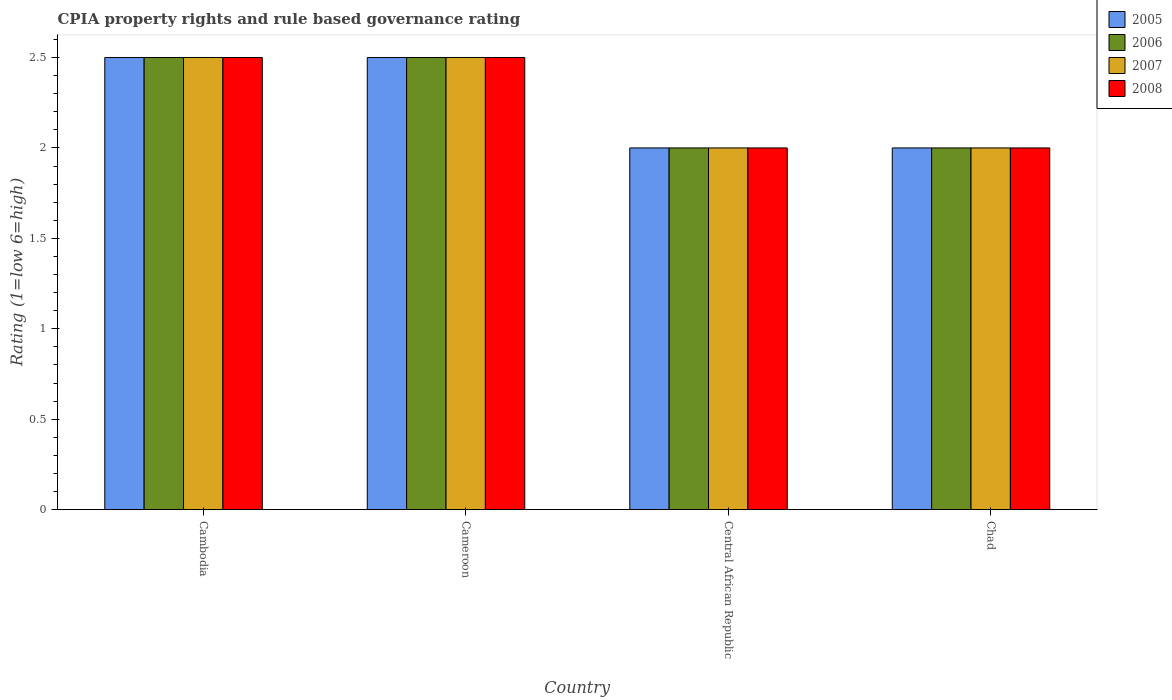Are the number of bars per tick equal to the number of legend labels?
Provide a succinct answer. Yes. Are the number of bars on each tick of the X-axis equal?
Offer a very short reply. Yes. How many bars are there on the 4th tick from the left?
Provide a succinct answer. 4. What is the label of the 4th group of bars from the left?
Provide a succinct answer. Chad. In how many cases, is the number of bars for a given country not equal to the number of legend labels?
Provide a succinct answer. 0. What is the CPIA rating in 2005 in Cambodia?
Provide a short and direct response. 2.5. Across all countries, what is the maximum CPIA rating in 2008?
Offer a terse response. 2.5. Across all countries, what is the minimum CPIA rating in 2008?
Your answer should be compact. 2. In which country was the CPIA rating in 2008 maximum?
Offer a terse response. Cambodia. In which country was the CPIA rating in 2007 minimum?
Your response must be concise. Central African Republic. What is the total CPIA rating in 2008 in the graph?
Provide a succinct answer. 9. What is the average CPIA rating in 2008 per country?
Provide a succinct answer. 2.25. What is the difference between the CPIA rating of/in 2005 and CPIA rating of/in 2008 in Central African Republic?
Offer a very short reply. 0. Is the CPIA rating in 2005 in Cambodia less than that in Central African Republic?
Your response must be concise. No. Is the difference between the CPIA rating in 2005 in Cameroon and Central African Republic greater than the difference between the CPIA rating in 2008 in Cameroon and Central African Republic?
Your response must be concise. No. In how many countries, is the CPIA rating in 2007 greater than the average CPIA rating in 2007 taken over all countries?
Provide a short and direct response. 2. How many bars are there?
Provide a succinct answer. 16. Are all the bars in the graph horizontal?
Your answer should be very brief. No. What is the difference between two consecutive major ticks on the Y-axis?
Give a very brief answer. 0.5. Does the graph contain grids?
Your answer should be very brief. No. Where does the legend appear in the graph?
Offer a terse response. Top right. How are the legend labels stacked?
Provide a short and direct response. Vertical. What is the title of the graph?
Offer a terse response. CPIA property rights and rule based governance rating. What is the label or title of the X-axis?
Your response must be concise. Country. What is the label or title of the Y-axis?
Your answer should be compact. Rating (1=low 6=high). What is the Rating (1=low 6=high) of 2005 in Cambodia?
Give a very brief answer. 2.5. What is the Rating (1=low 6=high) in 2006 in Cambodia?
Your response must be concise. 2.5. What is the Rating (1=low 6=high) of 2007 in Cambodia?
Ensure brevity in your answer.  2.5. What is the Rating (1=low 6=high) in 2008 in Cambodia?
Offer a very short reply. 2.5. What is the Rating (1=low 6=high) of 2005 in Cameroon?
Give a very brief answer. 2.5. What is the Rating (1=low 6=high) in 2008 in Cameroon?
Make the answer very short. 2.5. What is the Rating (1=low 6=high) of 2008 in Central African Republic?
Provide a succinct answer. 2. What is the Rating (1=low 6=high) of 2005 in Chad?
Your answer should be compact. 2. What is the Rating (1=low 6=high) in 2008 in Chad?
Keep it short and to the point. 2. Across all countries, what is the minimum Rating (1=low 6=high) of 2005?
Provide a succinct answer. 2. Across all countries, what is the minimum Rating (1=low 6=high) in 2006?
Provide a short and direct response. 2. Across all countries, what is the minimum Rating (1=low 6=high) of 2008?
Your answer should be very brief. 2. What is the total Rating (1=low 6=high) in 2006 in the graph?
Your answer should be very brief. 9. What is the total Rating (1=low 6=high) in 2008 in the graph?
Offer a terse response. 9. What is the difference between the Rating (1=low 6=high) in 2005 in Cambodia and that in Cameroon?
Your answer should be very brief. 0. What is the difference between the Rating (1=low 6=high) in 2007 in Cambodia and that in Cameroon?
Your response must be concise. 0. What is the difference between the Rating (1=low 6=high) in 2008 in Cambodia and that in Cameroon?
Offer a terse response. 0. What is the difference between the Rating (1=low 6=high) of 2005 in Cambodia and that in Central African Republic?
Provide a short and direct response. 0.5. What is the difference between the Rating (1=low 6=high) of 2006 in Cambodia and that in Central African Republic?
Give a very brief answer. 0.5. What is the difference between the Rating (1=low 6=high) of 2007 in Cambodia and that in Central African Republic?
Your response must be concise. 0.5. What is the difference between the Rating (1=low 6=high) of 2005 in Cambodia and that in Chad?
Your answer should be compact. 0.5. What is the difference between the Rating (1=low 6=high) in 2007 in Cambodia and that in Chad?
Your answer should be compact. 0.5. What is the difference between the Rating (1=low 6=high) of 2008 in Cambodia and that in Chad?
Your answer should be compact. 0.5. What is the difference between the Rating (1=low 6=high) of 2005 in Cameroon and that in Central African Republic?
Provide a short and direct response. 0.5. What is the difference between the Rating (1=low 6=high) of 2005 in Cameroon and that in Chad?
Your answer should be compact. 0.5. What is the difference between the Rating (1=low 6=high) in 2006 in Cameroon and that in Chad?
Make the answer very short. 0.5. What is the difference between the Rating (1=low 6=high) of 2007 in Cameroon and that in Chad?
Give a very brief answer. 0.5. What is the difference between the Rating (1=low 6=high) in 2005 in Central African Republic and that in Chad?
Provide a short and direct response. 0. What is the difference between the Rating (1=low 6=high) of 2006 in Central African Republic and that in Chad?
Your answer should be very brief. 0. What is the difference between the Rating (1=low 6=high) of 2007 in Central African Republic and that in Chad?
Your answer should be compact. 0. What is the difference between the Rating (1=low 6=high) of 2008 in Central African Republic and that in Chad?
Your answer should be very brief. 0. What is the difference between the Rating (1=low 6=high) in 2005 in Cambodia and the Rating (1=low 6=high) in 2006 in Cameroon?
Your answer should be compact. 0. What is the difference between the Rating (1=low 6=high) of 2005 in Cambodia and the Rating (1=low 6=high) of 2008 in Cameroon?
Provide a succinct answer. 0. What is the difference between the Rating (1=low 6=high) of 2006 in Cambodia and the Rating (1=low 6=high) of 2008 in Cameroon?
Give a very brief answer. 0. What is the difference between the Rating (1=low 6=high) of 2005 in Cambodia and the Rating (1=low 6=high) of 2007 in Central African Republic?
Your response must be concise. 0.5. What is the difference between the Rating (1=low 6=high) of 2006 in Cambodia and the Rating (1=low 6=high) of 2008 in Central African Republic?
Provide a succinct answer. 0.5. What is the difference between the Rating (1=low 6=high) in 2005 in Cambodia and the Rating (1=low 6=high) in 2006 in Chad?
Offer a very short reply. 0.5. What is the difference between the Rating (1=low 6=high) in 2005 in Cambodia and the Rating (1=low 6=high) in 2007 in Chad?
Offer a very short reply. 0.5. What is the difference between the Rating (1=low 6=high) of 2005 in Cameroon and the Rating (1=low 6=high) of 2006 in Central African Republic?
Offer a terse response. 0.5. What is the difference between the Rating (1=low 6=high) in 2007 in Cameroon and the Rating (1=low 6=high) in 2008 in Central African Republic?
Your answer should be very brief. 0.5. What is the difference between the Rating (1=low 6=high) of 2006 in Cameroon and the Rating (1=low 6=high) of 2007 in Chad?
Give a very brief answer. 0.5. What is the difference between the Rating (1=low 6=high) of 2005 in Central African Republic and the Rating (1=low 6=high) of 2007 in Chad?
Offer a very short reply. 0. What is the difference between the Rating (1=low 6=high) in 2006 in Central African Republic and the Rating (1=low 6=high) in 2008 in Chad?
Offer a terse response. 0. What is the difference between the Rating (1=low 6=high) in 2007 in Central African Republic and the Rating (1=low 6=high) in 2008 in Chad?
Your answer should be compact. 0. What is the average Rating (1=low 6=high) of 2005 per country?
Make the answer very short. 2.25. What is the average Rating (1=low 6=high) of 2006 per country?
Provide a short and direct response. 2.25. What is the average Rating (1=low 6=high) in 2007 per country?
Ensure brevity in your answer.  2.25. What is the average Rating (1=low 6=high) in 2008 per country?
Make the answer very short. 2.25. What is the difference between the Rating (1=low 6=high) of 2005 and Rating (1=low 6=high) of 2006 in Cambodia?
Provide a short and direct response. 0. What is the difference between the Rating (1=low 6=high) of 2005 and Rating (1=low 6=high) of 2007 in Cambodia?
Your answer should be very brief. 0. What is the difference between the Rating (1=low 6=high) in 2005 and Rating (1=low 6=high) in 2008 in Cambodia?
Your answer should be compact. 0. What is the difference between the Rating (1=low 6=high) in 2007 and Rating (1=low 6=high) in 2008 in Cambodia?
Keep it short and to the point. 0. What is the difference between the Rating (1=low 6=high) in 2005 and Rating (1=low 6=high) in 2006 in Cameroon?
Your answer should be compact. 0. What is the difference between the Rating (1=low 6=high) in 2005 and Rating (1=low 6=high) in 2007 in Cameroon?
Offer a very short reply. 0. What is the difference between the Rating (1=low 6=high) of 2006 and Rating (1=low 6=high) of 2007 in Cameroon?
Your response must be concise. 0. What is the difference between the Rating (1=low 6=high) of 2007 and Rating (1=low 6=high) of 2008 in Cameroon?
Your response must be concise. 0. What is the difference between the Rating (1=low 6=high) of 2005 and Rating (1=low 6=high) of 2007 in Central African Republic?
Ensure brevity in your answer.  0. What is the difference between the Rating (1=low 6=high) in 2005 and Rating (1=low 6=high) in 2008 in Central African Republic?
Keep it short and to the point. 0. What is the difference between the Rating (1=low 6=high) of 2006 and Rating (1=low 6=high) of 2007 in Central African Republic?
Your answer should be very brief. 0. What is the difference between the Rating (1=low 6=high) of 2005 and Rating (1=low 6=high) of 2006 in Chad?
Give a very brief answer. 0. What is the difference between the Rating (1=low 6=high) of 2005 and Rating (1=low 6=high) of 2008 in Chad?
Your response must be concise. 0. What is the difference between the Rating (1=low 6=high) of 2006 and Rating (1=low 6=high) of 2007 in Chad?
Keep it short and to the point. 0. What is the ratio of the Rating (1=low 6=high) in 2008 in Cambodia to that in Cameroon?
Ensure brevity in your answer.  1. What is the ratio of the Rating (1=low 6=high) of 2006 in Cambodia to that in Central African Republic?
Provide a succinct answer. 1.25. What is the ratio of the Rating (1=low 6=high) in 2005 in Cambodia to that in Chad?
Provide a succinct answer. 1.25. What is the ratio of the Rating (1=low 6=high) in 2006 in Cambodia to that in Chad?
Your response must be concise. 1.25. What is the ratio of the Rating (1=low 6=high) in 2007 in Cambodia to that in Chad?
Offer a very short reply. 1.25. What is the ratio of the Rating (1=low 6=high) of 2006 in Cameroon to that in Chad?
Ensure brevity in your answer.  1.25. What is the ratio of the Rating (1=low 6=high) in 2008 in Cameroon to that in Chad?
Make the answer very short. 1.25. What is the ratio of the Rating (1=low 6=high) in 2005 in Central African Republic to that in Chad?
Offer a very short reply. 1. What is the ratio of the Rating (1=low 6=high) of 2007 in Central African Republic to that in Chad?
Give a very brief answer. 1. What is the ratio of the Rating (1=low 6=high) in 2008 in Central African Republic to that in Chad?
Make the answer very short. 1. What is the difference between the highest and the second highest Rating (1=low 6=high) of 2006?
Offer a terse response. 0. What is the difference between the highest and the second highest Rating (1=low 6=high) of 2007?
Your answer should be very brief. 0. What is the difference between the highest and the lowest Rating (1=low 6=high) of 2006?
Your response must be concise. 0.5. 